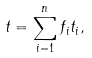<formula> <loc_0><loc_0><loc_500><loc_500>t = \sum _ { i = 1 } ^ { n } f _ { i } t _ { i } ,</formula> 